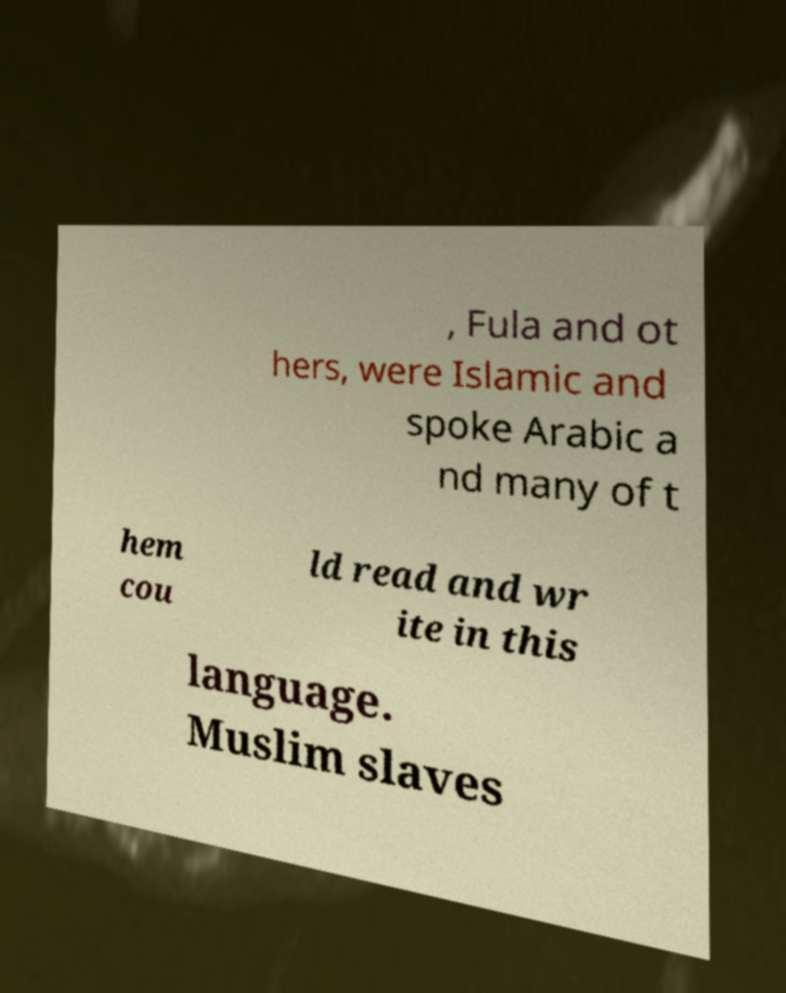Can you accurately transcribe the text from the provided image for me? , Fula and ot hers, were Islamic and spoke Arabic a nd many of t hem cou ld read and wr ite in this language. Muslim slaves 